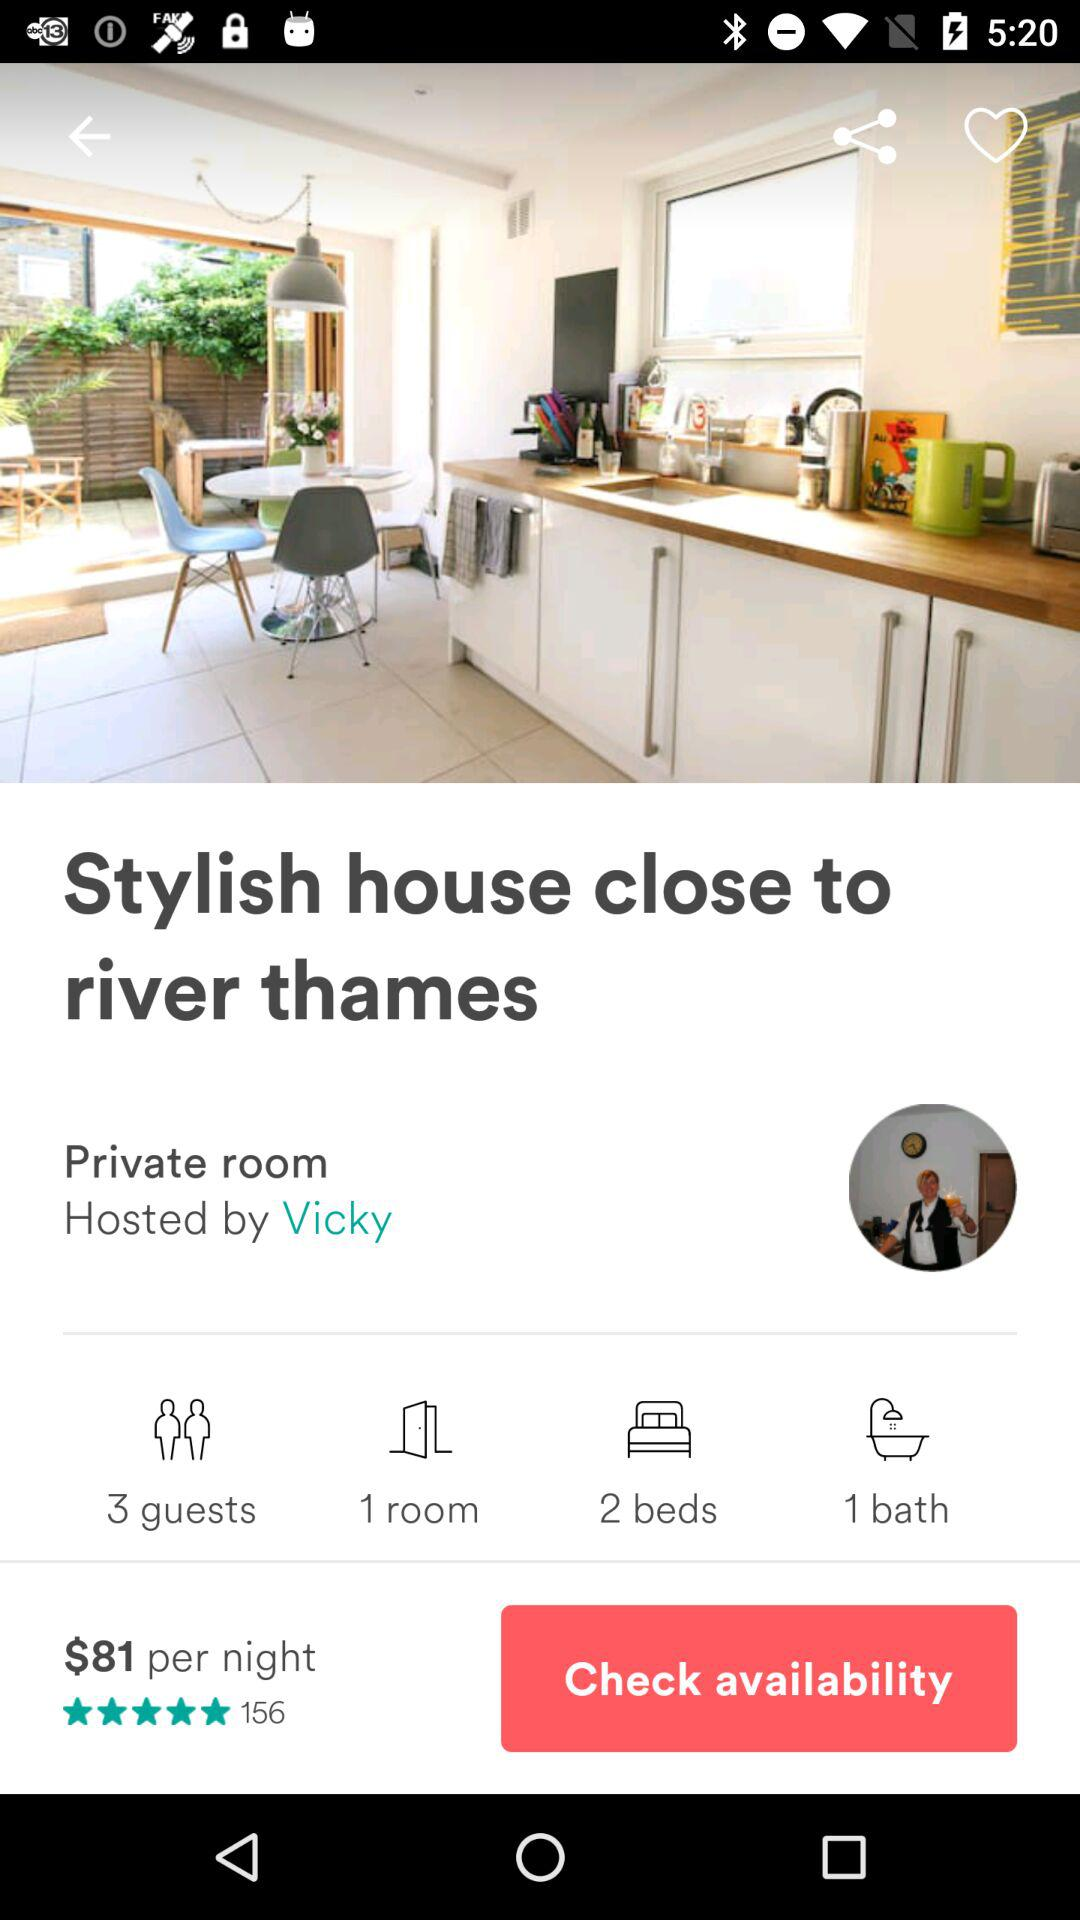Who's the host? The host is Vicky. 